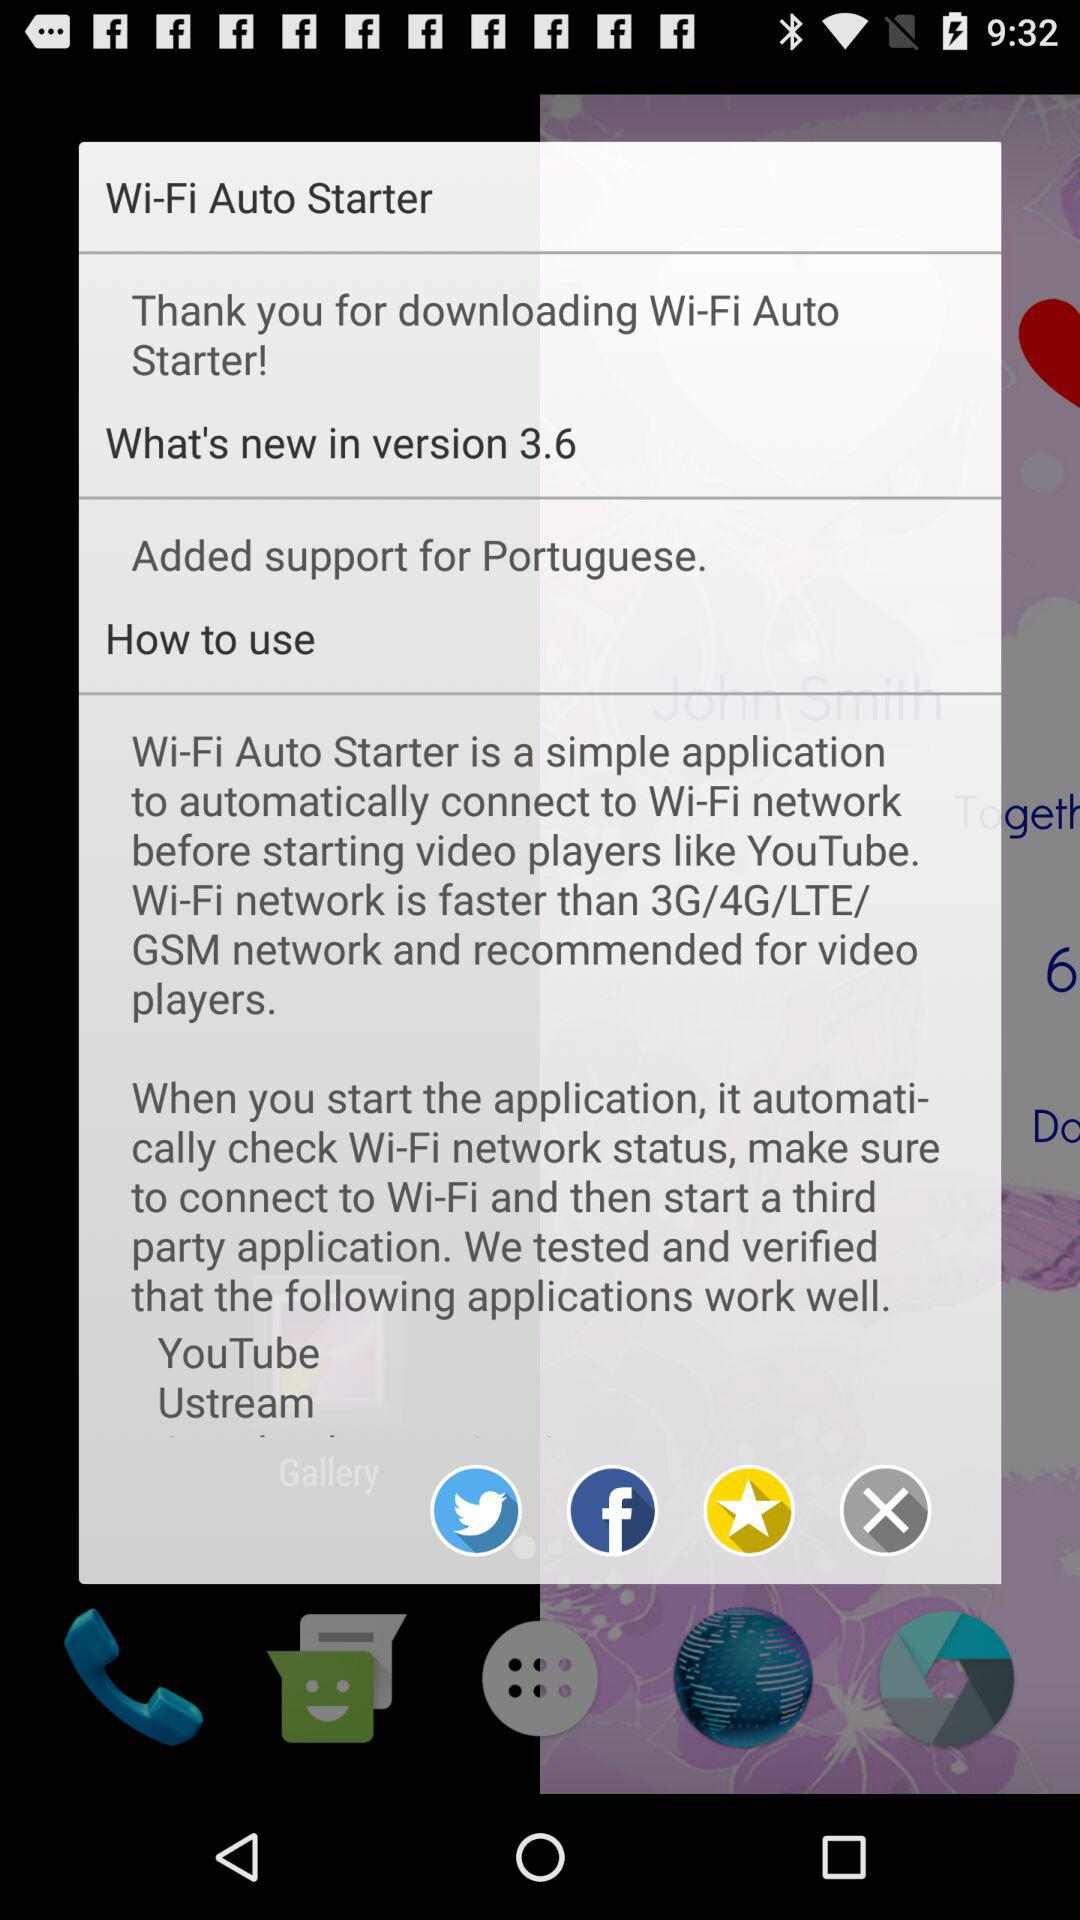What is the name of the application? The name of the application is "Wi-Fi Auto Starter". 